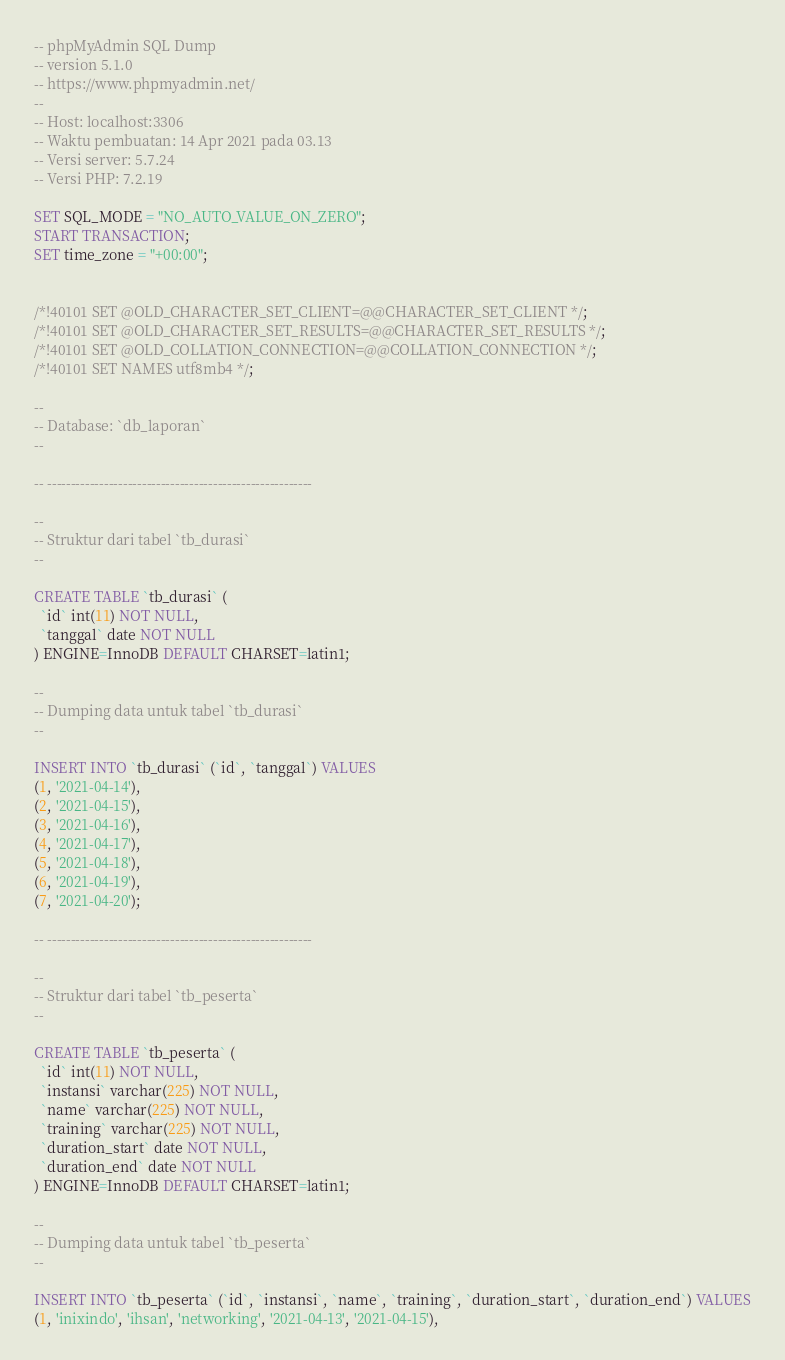<code> <loc_0><loc_0><loc_500><loc_500><_SQL_>-- phpMyAdmin SQL Dump
-- version 5.1.0
-- https://www.phpmyadmin.net/
--
-- Host: localhost:3306
-- Waktu pembuatan: 14 Apr 2021 pada 03.13
-- Versi server: 5.7.24
-- Versi PHP: 7.2.19

SET SQL_MODE = "NO_AUTO_VALUE_ON_ZERO";
START TRANSACTION;
SET time_zone = "+00:00";


/*!40101 SET @OLD_CHARACTER_SET_CLIENT=@@CHARACTER_SET_CLIENT */;
/*!40101 SET @OLD_CHARACTER_SET_RESULTS=@@CHARACTER_SET_RESULTS */;
/*!40101 SET @OLD_COLLATION_CONNECTION=@@COLLATION_CONNECTION */;
/*!40101 SET NAMES utf8mb4 */;

--
-- Database: `db_laporan`
--

-- --------------------------------------------------------

--
-- Struktur dari tabel `tb_durasi`
--

CREATE TABLE `tb_durasi` (
  `id` int(11) NOT NULL,
  `tanggal` date NOT NULL
) ENGINE=InnoDB DEFAULT CHARSET=latin1;

--
-- Dumping data untuk tabel `tb_durasi`
--

INSERT INTO `tb_durasi` (`id`, `tanggal`) VALUES
(1, '2021-04-14'),
(2, '2021-04-15'),
(3, '2021-04-16'),
(4, '2021-04-17'),
(5, '2021-04-18'),
(6, '2021-04-19'),
(7, '2021-04-20');

-- --------------------------------------------------------

--
-- Struktur dari tabel `tb_peserta`
--

CREATE TABLE `tb_peserta` (
  `id` int(11) NOT NULL,
  `instansi` varchar(225) NOT NULL,
  `name` varchar(225) NOT NULL,
  `training` varchar(225) NOT NULL,
  `duration_start` date NOT NULL,
  `duration_end` date NOT NULL
) ENGINE=InnoDB DEFAULT CHARSET=latin1;

--
-- Dumping data untuk tabel `tb_peserta`
--

INSERT INTO `tb_peserta` (`id`, `instansi`, `name`, `training`, `duration_start`, `duration_end`) VALUES
(1, 'inixindo', 'ihsan', 'networking', '2021-04-13', '2021-04-15'),</code> 